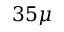Convert formula to latex. <formula><loc_0><loc_0><loc_500><loc_500>3 5 \mu</formula> 